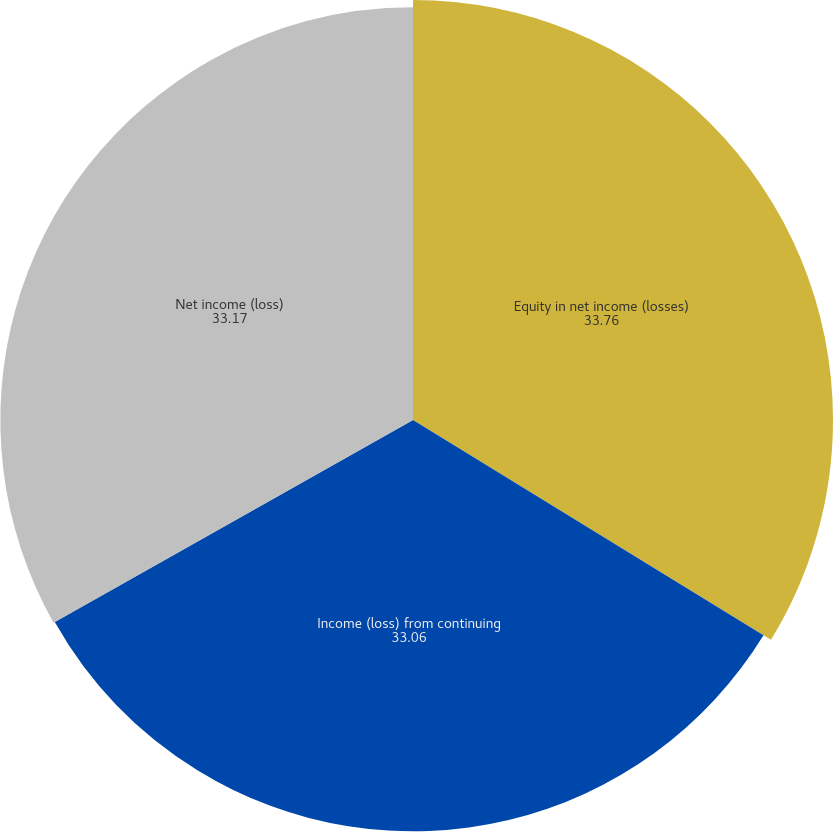<chart> <loc_0><loc_0><loc_500><loc_500><pie_chart><fcel>Equity in net income (losses)<fcel>Income (loss) from continuing<fcel>Net income (loss)<nl><fcel>33.76%<fcel>33.06%<fcel>33.17%<nl></chart> 